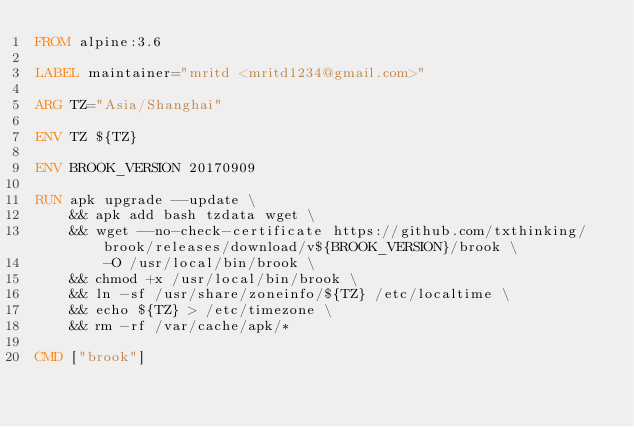<code> <loc_0><loc_0><loc_500><loc_500><_Dockerfile_>FROM alpine:3.6

LABEL maintainer="mritd <mritd1234@gmail.com>"

ARG TZ="Asia/Shanghai"

ENV TZ ${TZ}

ENV BROOK_VERSION 20170909

RUN apk upgrade --update \
    && apk add bash tzdata wget \
    && wget --no-check-certificate https://github.com/txthinking/brook/releases/download/v${BROOK_VERSION}/brook \
        -O /usr/local/bin/brook \
    && chmod +x /usr/local/bin/brook \
    && ln -sf /usr/share/zoneinfo/${TZ} /etc/localtime \
    && echo ${TZ} > /etc/timezone \
    && rm -rf /var/cache/apk/*

CMD ["brook"]
</code> 